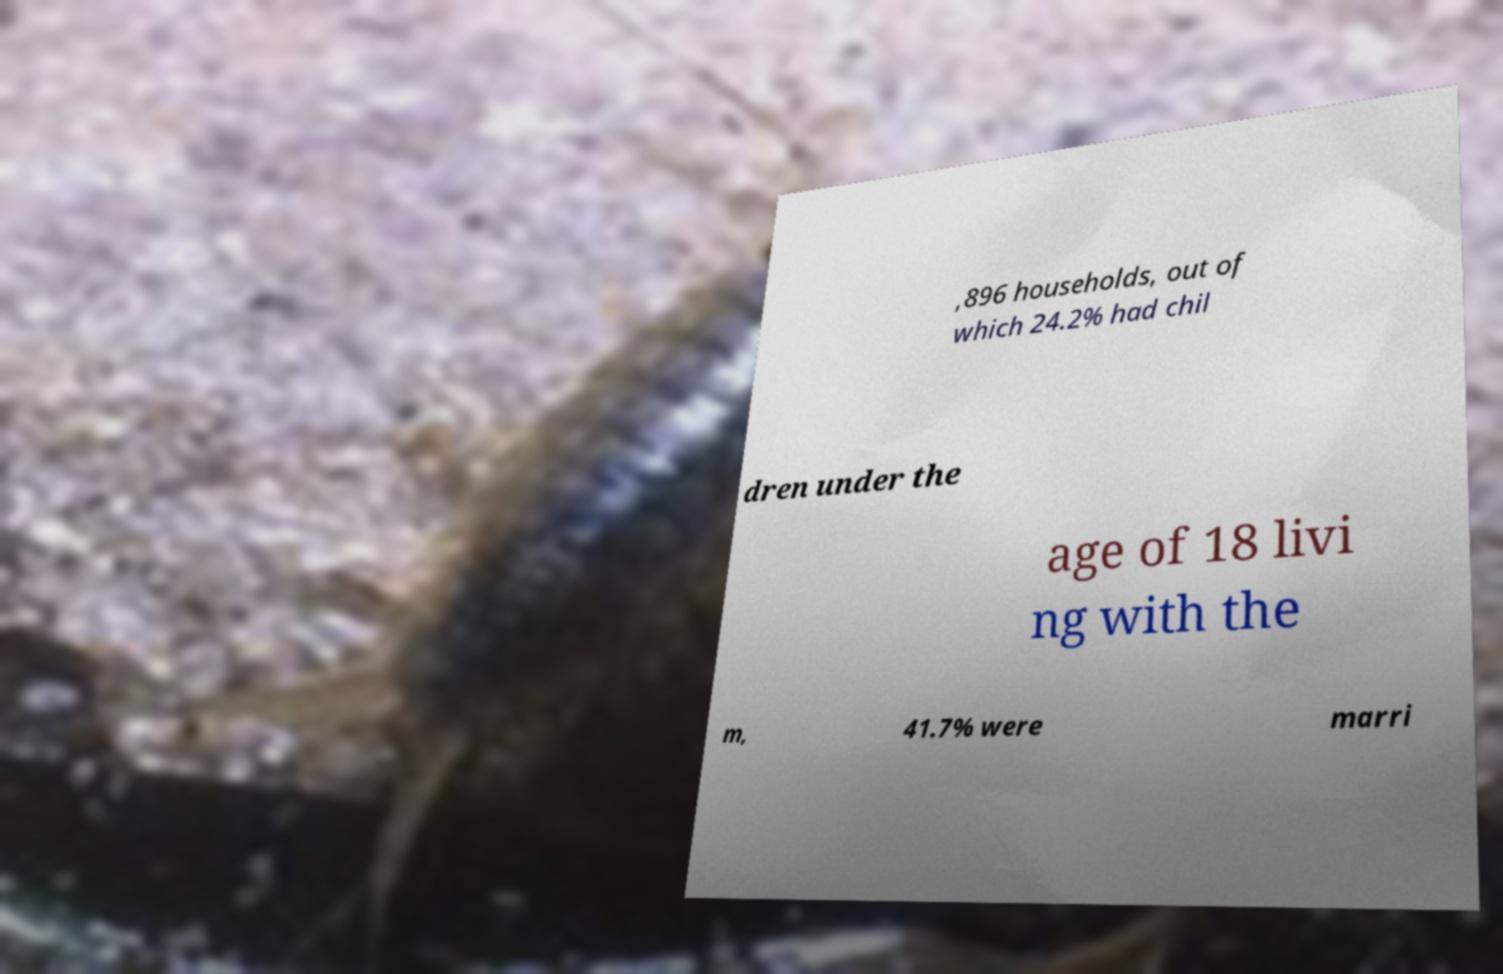Can you accurately transcribe the text from the provided image for me? ,896 households, out of which 24.2% had chil dren under the age of 18 livi ng with the m, 41.7% were marri 